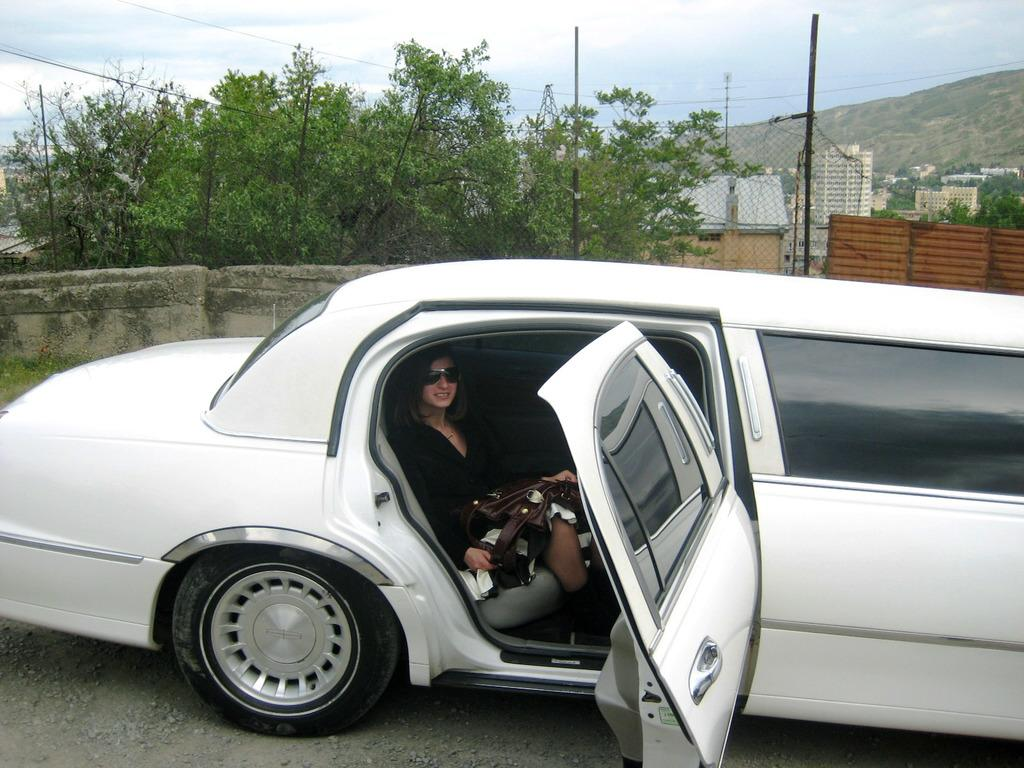What is the woman doing in the image? The woman is inside a car. What type of natural environment can be seen in the image? There are trees visible in the image. What type of man-made structures can be seen in the image? There are poles, a wall, and buildings visible in the image. What type of geographical feature can be seen in the image? There is a mountain visible in the image. What is visible in the background of the image? The sky is visible in the background of the image. What type of appliance is the woman using to communicate with someone in the image? There is no appliance visible in the image, and the woman's actions are not described in the provided facts. What color is the coat the woman is wearing in the image? The provided facts do not mention the woman wearing a coat, so we cannot determine the color. 